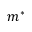<formula> <loc_0><loc_0><loc_500><loc_500>m ^ { * }</formula> 